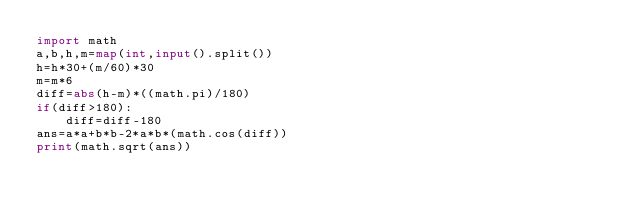<code> <loc_0><loc_0><loc_500><loc_500><_Python_>import math
a,b,h,m=map(int,input().split())
h=h*30+(m/60)*30
m=m*6
diff=abs(h-m)*((math.pi)/180)
if(diff>180):
    diff=diff-180
ans=a*a+b*b-2*a*b*(math.cos(diff))
print(math.sqrt(ans))
    </code> 